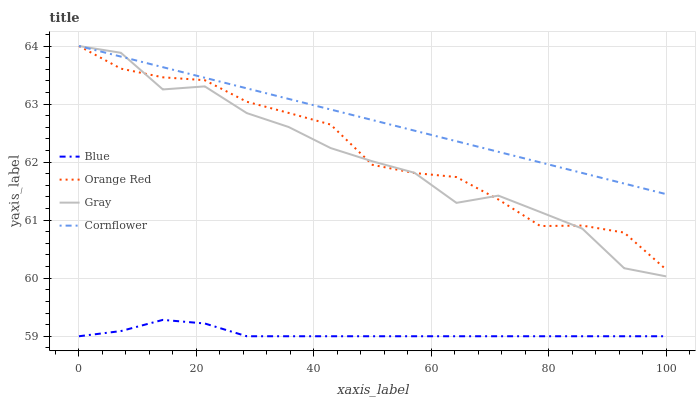Does Blue have the minimum area under the curve?
Answer yes or no. Yes. Does Cornflower have the maximum area under the curve?
Answer yes or no. Yes. Does Gray have the minimum area under the curve?
Answer yes or no. No. Does Gray have the maximum area under the curve?
Answer yes or no. No. Is Cornflower the smoothest?
Answer yes or no. Yes. Is Gray the roughest?
Answer yes or no. Yes. Is Orange Red the smoothest?
Answer yes or no. No. Is Orange Red the roughest?
Answer yes or no. No. Does Blue have the lowest value?
Answer yes or no. Yes. Does Gray have the lowest value?
Answer yes or no. No. Does Cornflower have the highest value?
Answer yes or no. Yes. Is Blue less than Cornflower?
Answer yes or no. Yes. Is Gray greater than Blue?
Answer yes or no. Yes. Does Cornflower intersect Orange Red?
Answer yes or no. Yes. Is Cornflower less than Orange Red?
Answer yes or no. No. Is Cornflower greater than Orange Red?
Answer yes or no. No. Does Blue intersect Cornflower?
Answer yes or no. No. 